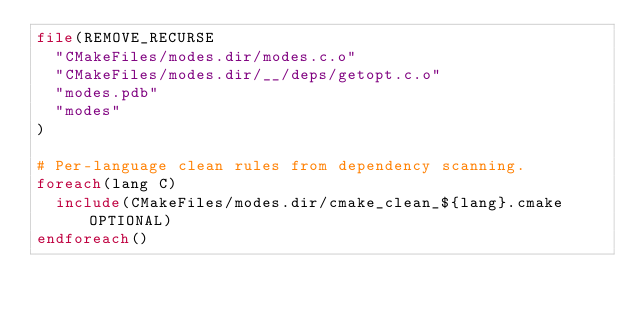Convert code to text. <code><loc_0><loc_0><loc_500><loc_500><_CMake_>file(REMOVE_RECURSE
  "CMakeFiles/modes.dir/modes.c.o"
  "CMakeFiles/modes.dir/__/deps/getopt.c.o"
  "modes.pdb"
  "modes"
)

# Per-language clean rules from dependency scanning.
foreach(lang C)
  include(CMakeFiles/modes.dir/cmake_clean_${lang}.cmake OPTIONAL)
endforeach()
</code> 